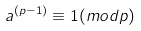<formula> <loc_0><loc_0><loc_500><loc_500>a ^ { ( p - 1 ) } \equiv 1 ( m o d p )</formula> 